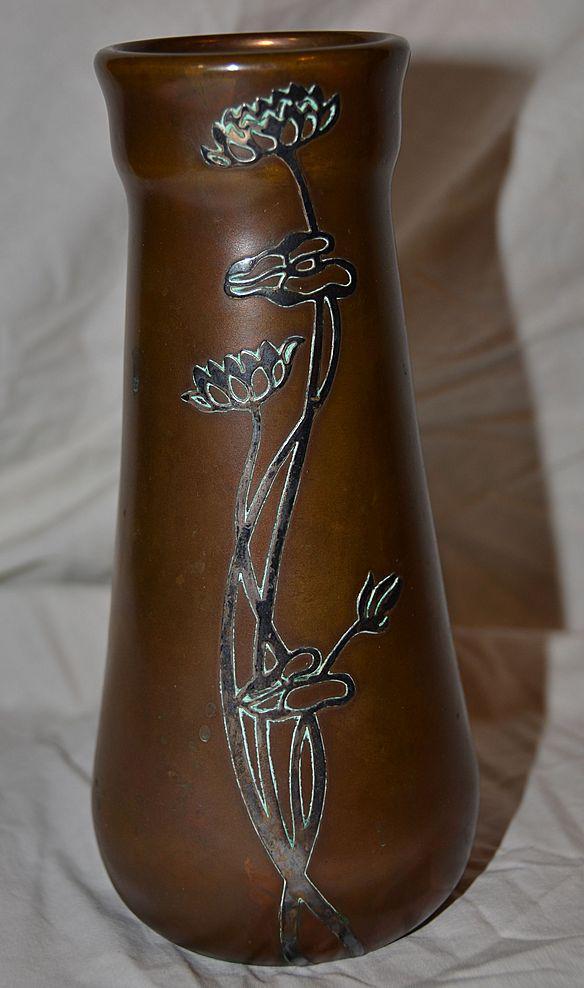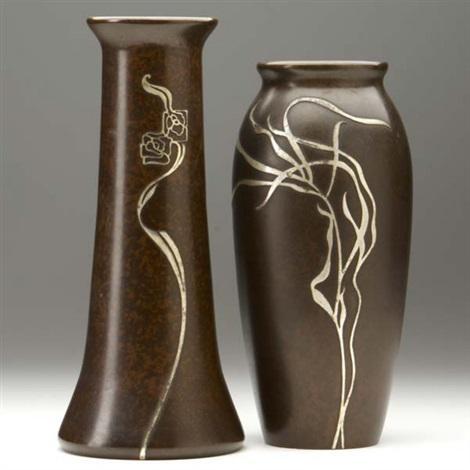The first image is the image on the left, the second image is the image on the right. Considering the images on both sides, is "There is an artistic ceramic vase with decorative patterns in the center of each image." valid? Answer yes or no. Yes. The first image is the image on the left, the second image is the image on the right. Considering the images on both sides, is "In one image the vase has a square tip and in the other the vase has a convex body" valid? Answer yes or no. No. The first image is the image on the left, the second image is the image on the right. Evaluate the accuracy of this statement regarding the images: "An image includes a vase that tapers to a narrower base from a flat top and has a foliage-themed design on it.". Is it true? Answer yes or no. Yes. 